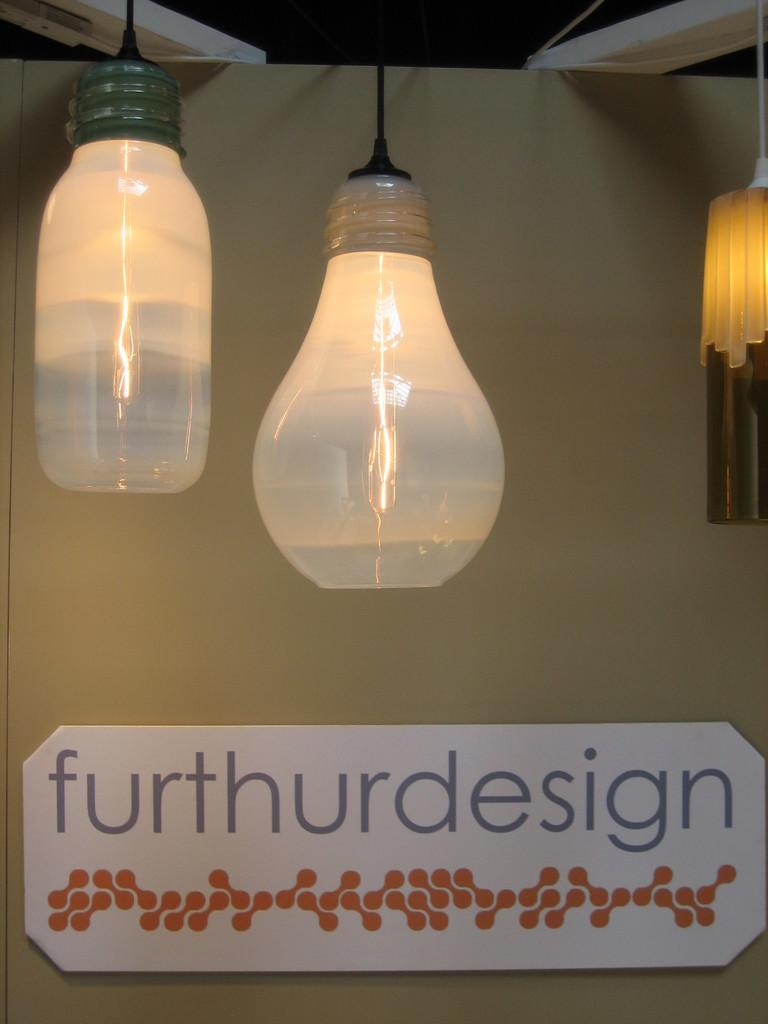<image>
Describe the image concisely. A decor setting that shows mason jar style lights hanging from above a sign that reads Furthurdesign 